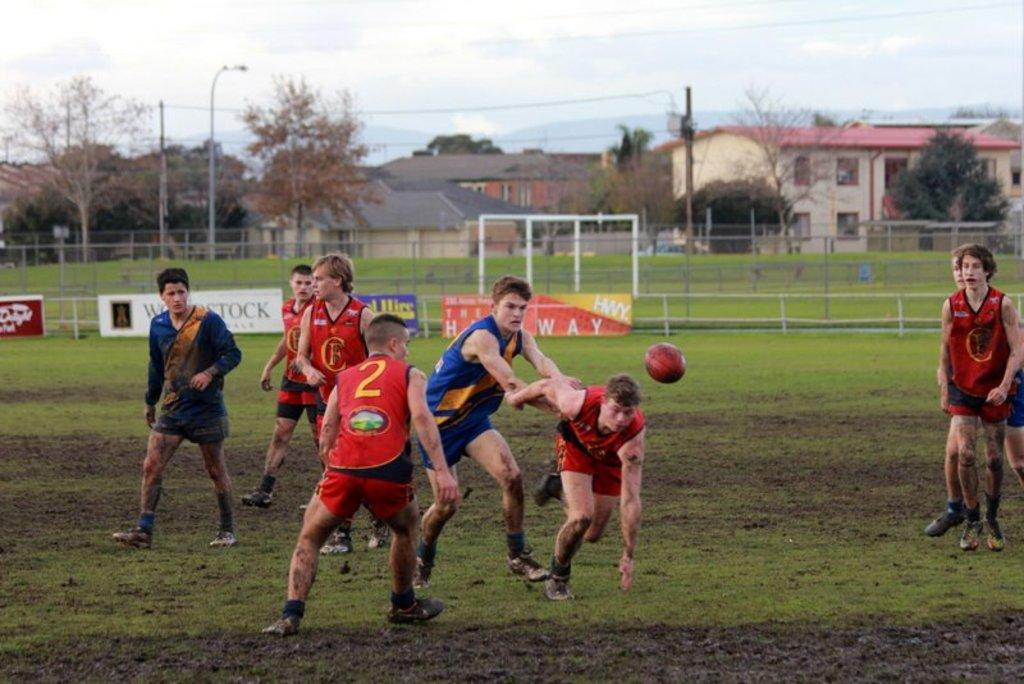Provide a one-sentence caption for the provided image. Player number 2 crouches in preparation for going after the ball. 